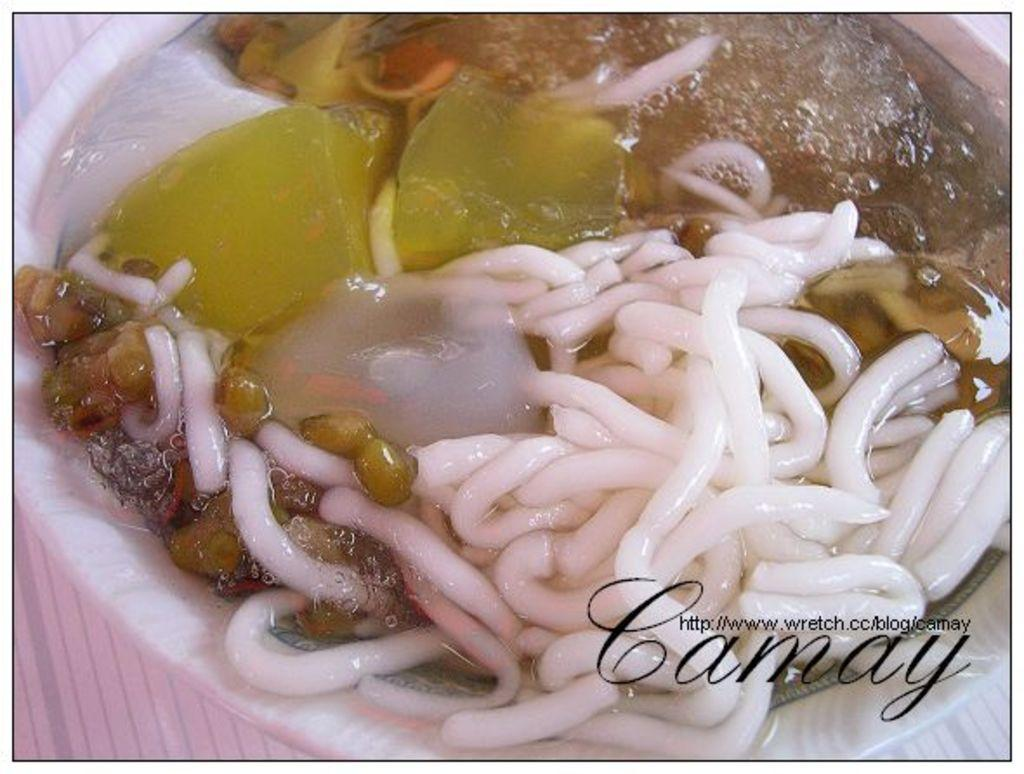What type of food is present in the image? There are noodles, nuts, and veggies in the image. What else can be seen in the image besides the food items? There is a bowl of soup in the image. What type of payment is required for the doctor in the image? There is no doctor or payment present in the image. What type of soap is used to clean the veggies in the image? There is no soap or indication of cleaning the veggies in the image. 